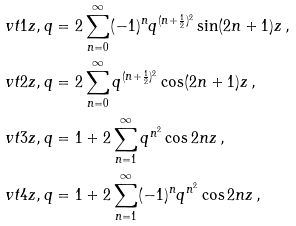Convert formula to latex. <formula><loc_0><loc_0><loc_500><loc_500>\ v t { 1 } { z , q } & = 2 \sum _ { n = 0 } ^ { \infty } ( - 1 ) ^ { n } q ^ { ( n + \frac { 1 } { 2 } ) ^ { 2 } } \sin ( 2 n + 1 ) z \, , \\ \ v t { 2 } { z , q } & = 2 \sum _ { n = 0 } ^ { \infty } q ^ { ( n + \frac { 1 } { 2 } ) ^ { 2 } } \cos ( 2 n + 1 ) z \, , \\ \ v t { 3 } { z , q } & = 1 + 2 \sum _ { n = 1 } ^ { \infty } q ^ { n ^ { 2 } } \cos 2 n z \, , \\ \ v t { 4 } { z , q } & = 1 + 2 \sum _ { n = 1 } ^ { \infty } ( - 1 ) ^ { n } q ^ { n ^ { 2 } } \cos 2 n z \, ,</formula> 